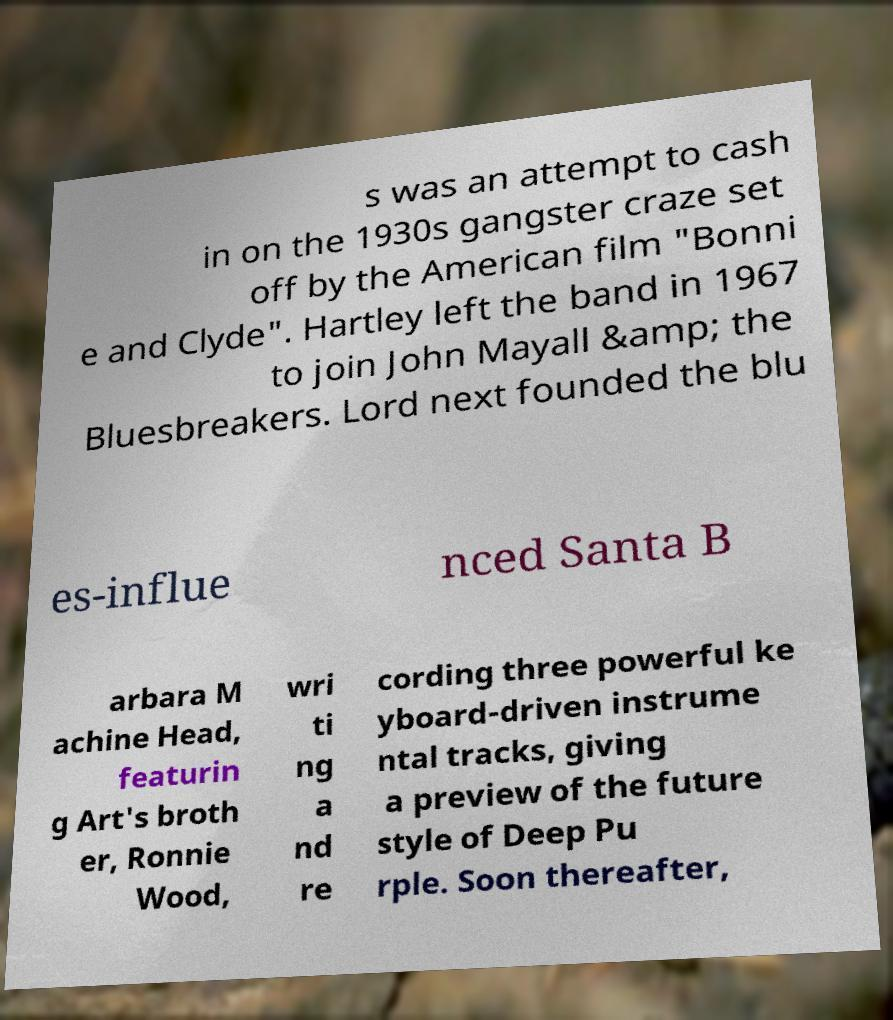I need the written content from this picture converted into text. Can you do that? s was an attempt to cash in on the 1930s gangster craze set off by the American film "Bonni e and Clyde". Hartley left the band in 1967 to join John Mayall &amp; the Bluesbreakers. Lord next founded the blu es-influe nced Santa B arbara M achine Head, featurin g Art's broth er, Ronnie Wood, wri ti ng a nd re cording three powerful ke yboard-driven instrume ntal tracks, giving a preview of the future style of Deep Pu rple. Soon thereafter, 